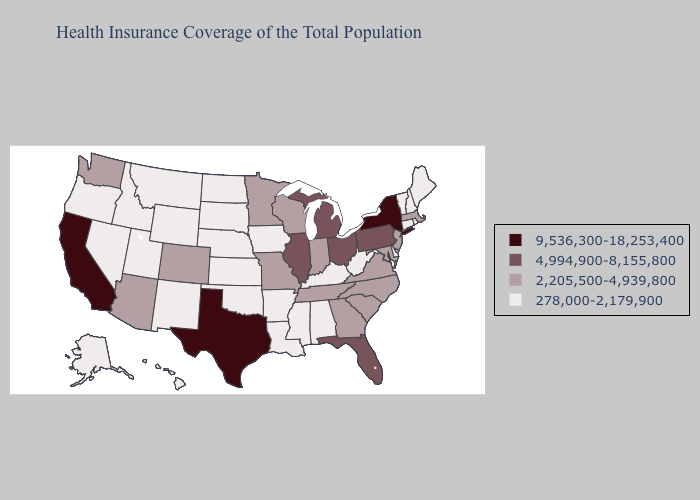Which states have the lowest value in the West?
Concise answer only. Alaska, Hawaii, Idaho, Montana, Nevada, New Mexico, Oregon, Utah, Wyoming. Does California have the lowest value in the West?
Quick response, please. No. Does Idaho have the highest value in the USA?
Give a very brief answer. No. Is the legend a continuous bar?
Concise answer only. No. Which states have the lowest value in the South?
Concise answer only. Alabama, Arkansas, Delaware, Kentucky, Louisiana, Mississippi, Oklahoma, West Virginia. Does Wyoming have the same value as Tennessee?
Short answer required. No. Does Oklahoma have the same value as Oregon?
Answer briefly. Yes. Name the states that have a value in the range 278,000-2,179,900?
Be succinct. Alabama, Alaska, Arkansas, Connecticut, Delaware, Hawaii, Idaho, Iowa, Kansas, Kentucky, Louisiana, Maine, Mississippi, Montana, Nebraska, Nevada, New Hampshire, New Mexico, North Dakota, Oklahoma, Oregon, Rhode Island, South Dakota, Utah, Vermont, West Virginia, Wyoming. Is the legend a continuous bar?
Quick response, please. No. What is the highest value in states that border Vermont?
Give a very brief answer. 9,536,300-18,253,400. What is the highest value in the USA?
Be succinct. 9,536,300-18,253,400. Does the first symbol in the legend represent the smallest category?
Keep it brief. No. Among the states that border Pennsylvania , does Delaware have the lowest value?
Write a very short answer. Yes. Name the states that have a value in the range 2,205,500-4,939,800?
Quick response, please. Arizona, Colorado, Georgia, Indiana, Maryland, Massachusetts, Minnesota, Missouri, New Jersey, North Carolina, South Carolina, Tennessee, Virginia, Washington, Wisconsin. Does New Mexico have the same value as California?
Give a very brief answer. No. 